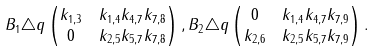Convert formula to latex. <formula><loc_0><loc_0><loc_500><loc_500>B _ { 1 } & \triangle q \begin{pmatrix} k _ { 1 , 3 } & k _ { 1 , 4 } k _ { 4 , 7 } k _ { 7 , 8 } \\ 0 & k _ { 2 , 5 } k _ { 5 , 7 } k _ { 7 , 8 } \end{pmatrix} , B _ { 2 } \triangle q \begin{pmatrix} 0 & k _ { 1 , 4 } k _ { 4 , 7 } k _ { 7 , 9 } \\ k _ { 2 , 6 } & k _ { 2 , 5 } k _ { 5 , 7 } k _ { 7 , 9 } \end{pmatrix} .</formula> 